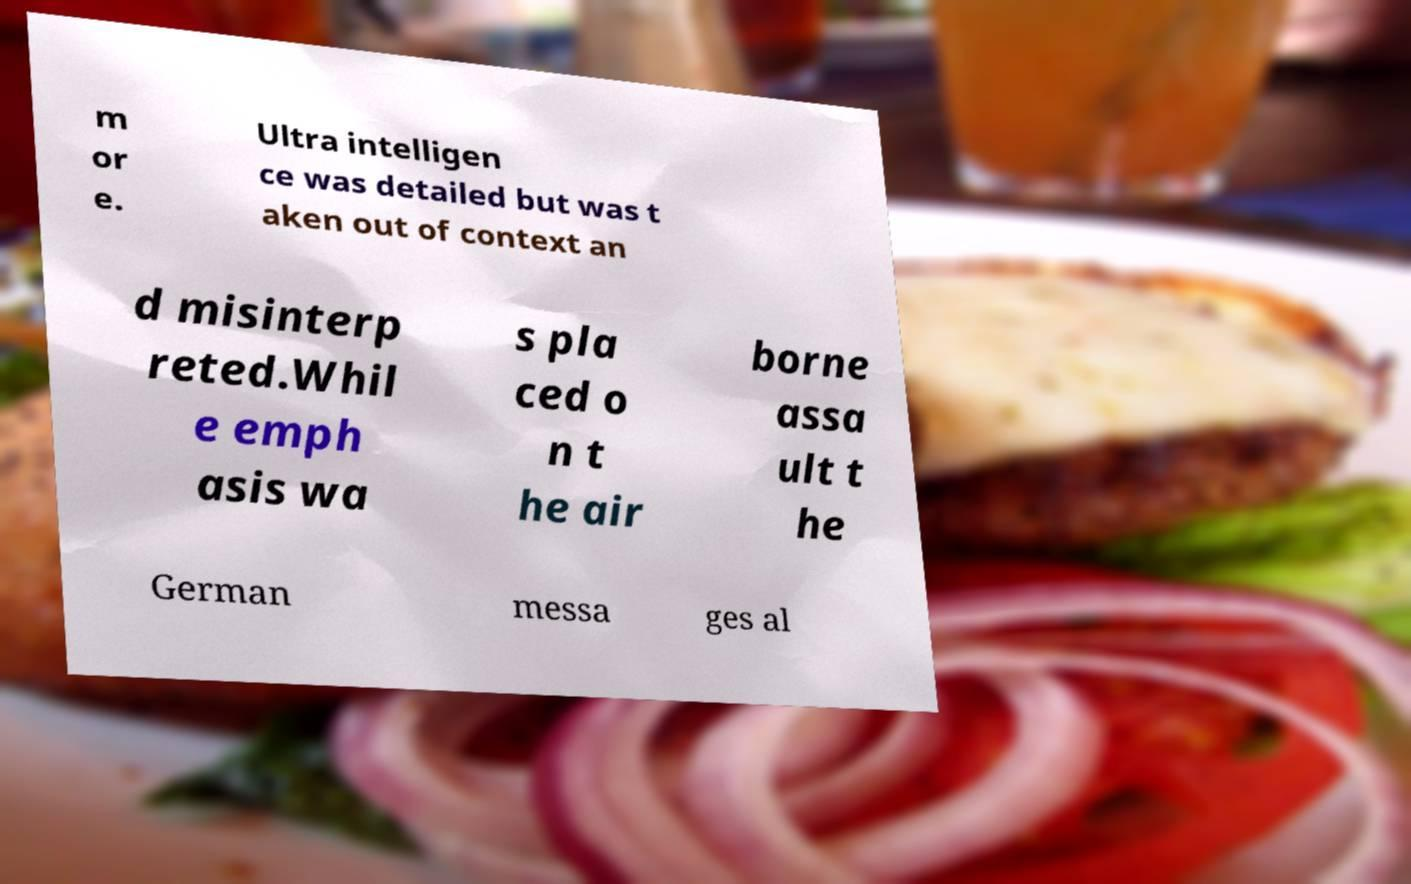There's text embedded in this image that I need extracted. Can you transcribe it verbatim? m or e. Ultra intelligen ce was detailed but was t aken out of context an d misinterp reted.Whil e emph asis wa s pla ced o n t he air borne assa ult t he German messa ges al 